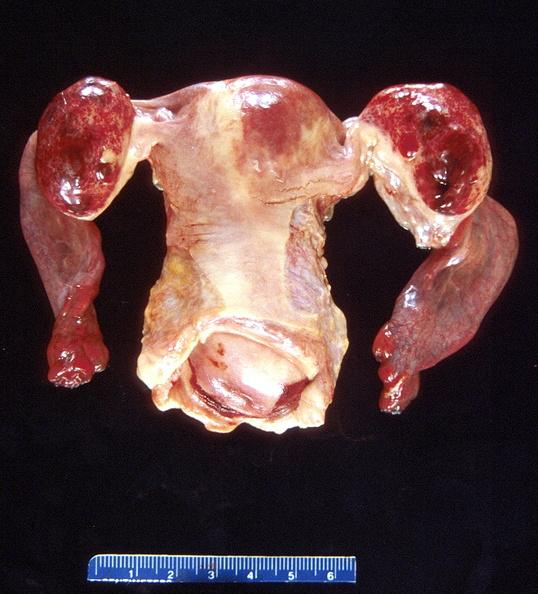what does this image show?
Answer the question using a single word or phrase. Ovarian cysts 